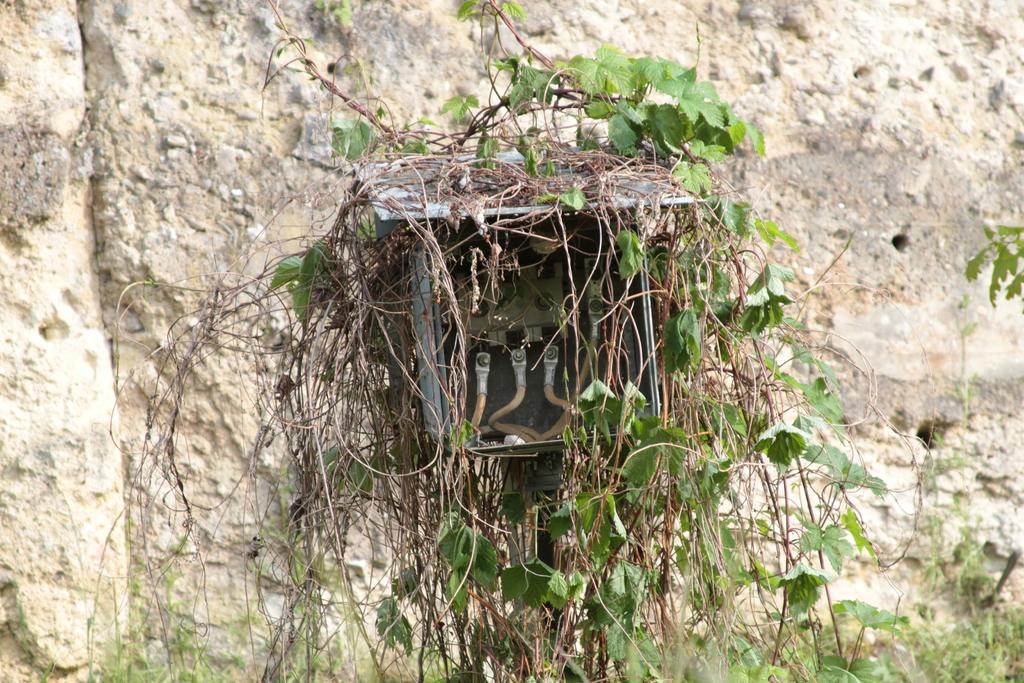What is inside the box that is visible in the image? There are cables in a box in the image. What type of living organisms can be seen in the image? There are plants in the image. What is visible in the background of the image? There is a wall in the background of the image. What letters are being written with a pen in the image? There are no letters or pens present in the image. What is the front of the image showing? The provided facts do not mention a "front" of the image, so it cannot be determined from the information given. 